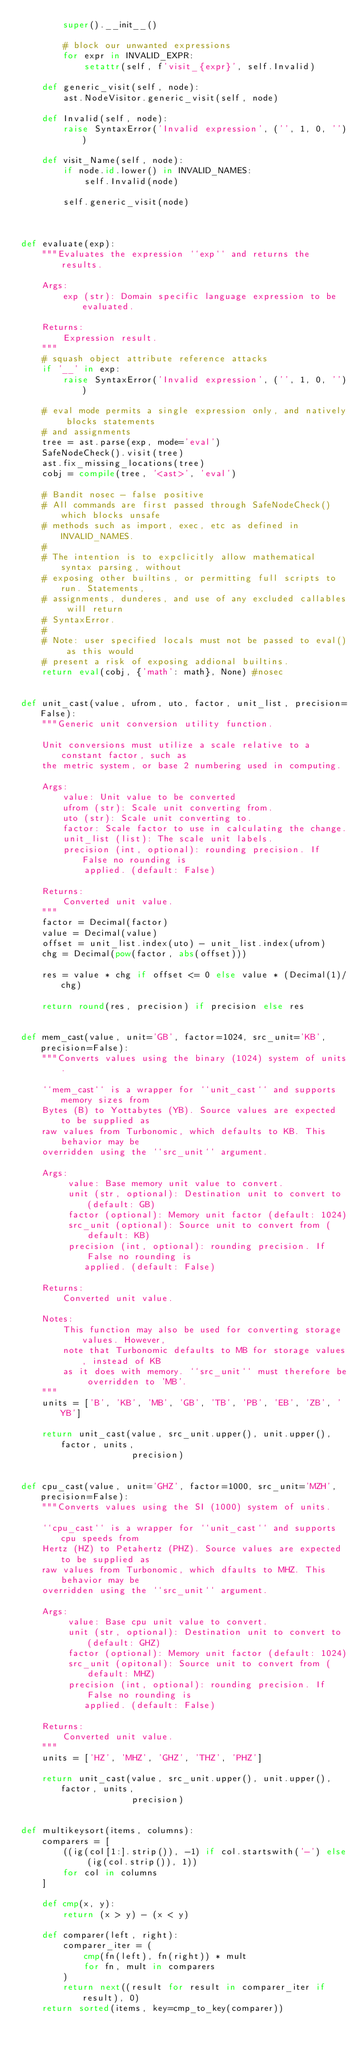<code> <loc_0><loc_0><loc_500><loc_500><_Python_>        super().__init__()

        # block our unwanted expressions
        for expr in INVALID_EXPR:
            setattr(self, f'visit_{expr}', self.Invalid)

    def generic_visit(self, node):
        ast.NodeVisitor.generic_visit(self, node)

    def Invalid(self, node):
        raise SyntaxError('Invalid expression', ('', 1, 0, ''))

    def visit_Name(self, node):
        if node.id.lower() in INVALID_NAMES:
            self.Invalid(node)

        self.generic_visit(node)



def evaluate(exp):
    """Evaluates the expression ``exp`` and returns the results.

    Args:
        exp (str): Domain specific language expression to be evaluated.

    Returns:
        Expression result.
    """
    # squash object attribute reference attacks
    if '__' in exp:
        raise SyntaxError('Invalid expression', ('', 1, 0, ''))

    # eval mode permits a single expression only, and natively blocks statements
    # and assignments
    tree = ast.parse(exp, mode='eval')
    SafeNodeCheck().visit(tree)
    ast.fix_missing_locations(tree)
    cobj = compile(tree, '<ast>', 'eval')

    # Bandit nosec - false positive
    # All commands are first passed through SafeNodeCheck() which blocks unsafe
    # methods such as import, exec, etc as defined in INVALID_NAMES.
    #
    # The intention is to expclicitly allow mathematical syntax parsing, without
    # exposing other builtins, or permitting full scripts to run. Statements,
    # assignments, dunderes, and use of any excluded callables will return
    # SyntaxError.
    #
    # Note: user specified locals must not be passed to eval() as this would
    # present a risk of exposing addional builtins.
    return eval(cobj, {'math': math}, None) #nosec


def unit_cast(value, ufrom, uto, factor, unit_list, precision=False):
    """Generic unit conversion utility function.

    Unit conversions must utilize a scale relative to a constant factor, such as
    the metric system, or base 2 numbering used in computing.

    Args:
        value: Unit value to be converted
        ufrom (str): Scale unit converting from.
        uto (str): Scale unit converting to.
        factor: Scale factor to use in calculating the change.
        unit_list (list): The scale unit labels.
        precision (int, optional): rounding precision. If False no rounding is
            applied. (default: False)

    Returns:
        Converted unit value.
    """
    factor = Decimal(factor)
    value = Decimal(value)
    offset = unit_list.index(uto) - unit_list.index(ufrom)
    chg = Decimal(pow(factor, abs(offset)))

    res = value * chg if offset <= 0 else value * (Decimal(1)/chg)

    return round(res, precision) if precision else res


def mem_cast(value, unit='GB', factor=1024, src_unit='KB', precision=False):
    """Converts values using the binary (1024) system of units.

    ``mem_cast`` is a wrapper for ``unit_cast`` and supports memory sizes from
    Bytes (B) to Yottabytes (YB). Source values are expected to be supplied as
    raw values from Turbonomic, which defaults to KB. This behavior may be
    overridden using the ``src_unit`` argument.

    Args:
         value: Base memory unit value to convert.
         unit (str, optional): Destination unit to convert to (default: GB)
         factor (optional): Memory unit factor (default: 1024)
         src_unit (optional): Source unit to convert from (default: KB)
         precision (int, optional): rounding precision. If False no rounding is
            applied. (default: False)

    Returns:
        Converted unit value.

    Notes:
        This function may also be used for converting storage values. However,
        note that Turbonomic defaults to MB for storage values, instead of KB
        as it does with memory. ``src_unit`` must therefore be overridden to 'MB'.
    """
    units = ['B', 'KB', 'MB', 'GB', 'TB', 'PB', 'EB', 'ZB', 'YB']

    return unit_cast(value, src_unit.upper(), unit.upper(), factor, units,
                     precision)


def cpu_cast(value, unit='GHZ', factor=1000, src_unit='MZH', precision=False):
    """Converts values using the SI (1000) system of units.

    ``cpu_cast`` is a wrapper for ``unit_cast`` and supports cpu speeds from
    Hertz (HZ) to Petahertz (PHZ). Source values are expected to be supplied as
    raw values from Turbonomic, which dfaults to MHZ. This behavior may be
    overridden using the ``src_unit`` argument.

    Args:
         value: Base cpu unit value to convert.
         unit (str, optional): Destination unit to convert to (default: GHZ)
         factor (optional): Memory unit factor (default: 1024)
         src_unit (opitonal): Source unit to convert from (default: MHZ)
         precision (int, optional): rounding precision. If False no rounding is
            applied. (default: False)

    Returns:
        Converted unit value.
    """
    units = ['HZ', 'MHZ', 'GHZ', 'THZ', 'PHZ']

    return unit_cast(value, src_unit.upper(), unit.upper(), factor, units,
                     precision)


def multikeysort(items, columns):
    comparers = [
        ((ig(col[1:].strip()), -1) if col.startswith('-') else (ig(col.strip()), 1))
        for col in columns
    ]

    def cmp(x, y):
        return (x > y) - (x < y)

    def comparer(left, right):
        comparer_iter = (
            cmp(fn(left), fn(right)) * mult
            for fn, mult in comparers
        )
        return next((result for result in comparer_iter if result), 0)
    return sorted(items, key=cmp_to_key(comparer))
</code> 